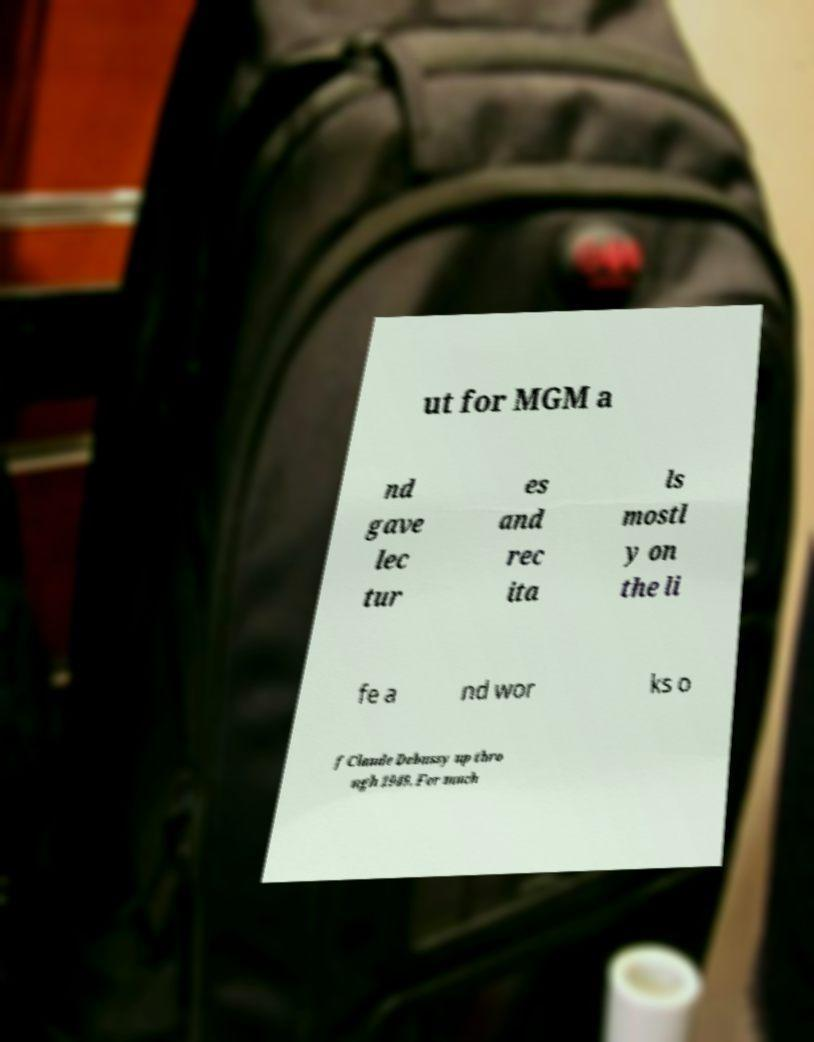Can you accurately transcribe the text from the provided image for me? ut for MGM a nd gave lec tur es and rec ita ls mostl y on the li fe a nd wor ks o f Claude Debussy up thro ugh 1949. For much 